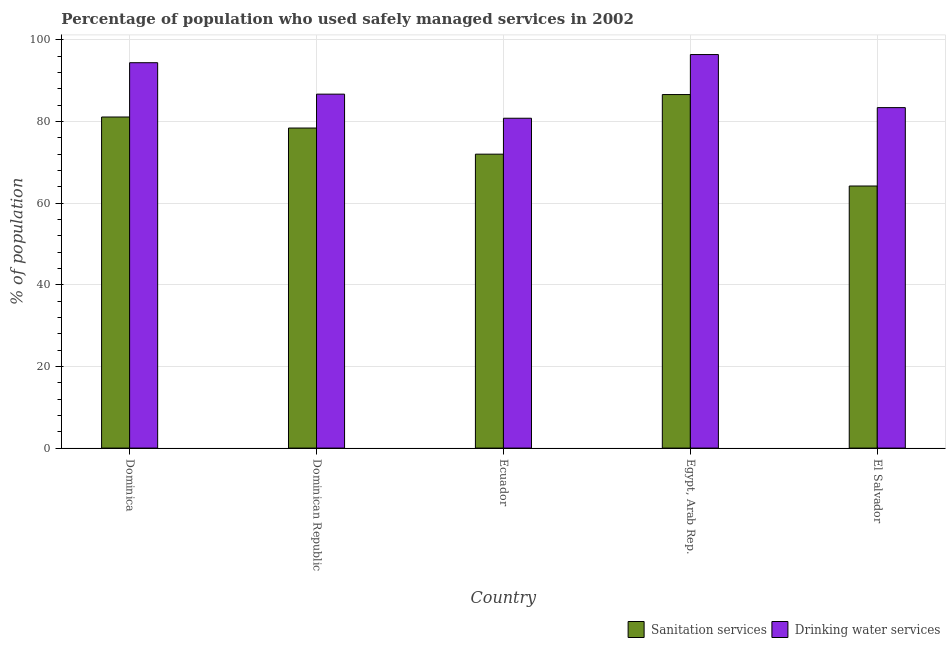Are the number of bars per tick equal to the number of legend labels?
Provide a short and direct response. Yes. Are the number of bars on each tick of the X-axis equal?
Provide a succinct answer. Yes. How many bars are there on the 2nd tick from the left?
Give a very brief answer. 2. What is the label of the 3rd group of bars from the left?
Provide a succinct answer. Ecuador. Across all countries, what is the maximum percentage of population who used sanitation services?
Your answer should be compact. 86.6. Across all countries, what is the minimum percentage of population who used drinking water services?
Your answer should be very brief. 80.8. In which country was the percentage of population who used sanitation services maximum?
Ensure brevity in your answer.  Egypt, Arab Rep. In which country was the percentage of population who used sanitation services minimum?
Make the answer very short. El Salvador. What is the total percentage of population who used sanitation services in the graph?
Give a very brief answer. 382.3. What is the difference between the percentage of population who used drinking water services in Dominican Republic and that in Egypt, Arab Rep.?
Your response must be concise. -9.7. What is the average percentage of population who used drinking water services per country?
Provide a short and direct response. 88.34. What is the difference between the percentage of population who used drinking water services and percentage of population who used sanitation services in Egypt, Arab Rep.?
Ensure brevity in your answer.  9.8. What is the ratio of the percentage of population who used drinking water services in Ecuador to that in Egypt, Arab Rep.?
Ensure brevity in your answer.  0.84. Is the percentage of population who used drinking water services in Dominica less than that in Dominican Republic?
Offer a very short reply. No. Is the difference between the percentage of population who used drinking water services in Ecuador and Egypt, Arab Rep. greater than the difference between the percentage of population who used sanitation services in Ecuador and Egypt, Arab Rep.?
Your answer should be very brief. No. What is the difference between the highest and the lowest percentage of population who used sanitation services?
Your answer should be compact. 22.4. In how many countries, is the percentage of population who used drinking water services greater than the average percentage of population who used drinking water services taken over all countries?
Your response must be concise. 2. What does the 2nd bar from the left in El Salvador represents?
Your answer should be very brief. Drinking water services. What does the 2nd bar from the right in Egypt, Arab Rep. represents?
Make the answer very short. Sanitation services. How many bars are there?
Offer a terse response. 10. Are all the bars in the graph horizontal?
Make the answer very short. No. What is the difference between two consecutive major ticks on the Y-axis?
Make the answer very short. 20. Does the graph contain any zero values?
Your response must be concise. No. How many legend labels are there?
Make the answer very short. 2. What is the title of the graph?
Offer a very short reply. Percentage of population who used safely managed services in 2002. What is the label or title of the Y-axis?
Ensure brevity in your answer.  % of population. What is the % of population of Sanitation services in Dominica?
Provide a short and direct response. 81.1. What is the % of population of Drinking water services in Dominica?
Provide a succinct answer. 94.4. What is the % of population of Sanitation services in Dominican Republic?
Offer a very short reply. 78.4. What is the % of population in Drinking water services in Dominican Republic?
Offer a terse response. 86.7. What is the % of population of Drinking water services in Ecuador?
Your answer should be very brief. 80.8. What is the % of population of Sanitation services in Egypt, Arab Rep.?
Your response must be concise. 86.6. What is the % of population of Drinking water services in Egypt, Arab Rep.?
Make the answer very short. 96.4. What is the % of population in Sanitation services in El Salvador?
Offer a very short reply. 64.2. What is the % of population in Drinking water services in El Salvador?
Provide a short and direct response. 83.4. Across all countries, what is the maximum % of population in Sanitation services?
Offer a terse response. 86.6. Across all countries, what is the maximum % of population of Drinking water services?
Make the answer very short. 96.4. Across all countries, what is the minimum % of population of Sanitation services?
Give a very brief answer. 64.2. Across all countries, what is the minimum % of population in Drinking water services?
Provide a short and direct response. 80.8. What is the total % of population of Sanitation services in the graph?
Your answer should be very brief. 382.3. What is the total % of population in Drinking water services in the graph?
Provide a short and direct response. 441.7. What is the difference between the % of population of Drinking water services in Dominica and that in Dominican Republic?
Provide a succinct answer. 7.7. What is the difference between the % of population in Sanitation services in Dominica and that in Ecuador?
Your response must be concise. 9.1. What is the difference between the % of population of Drinking water services in Dominica and that in Ecuador?
Make the answer very short. 13.6. What is the difference between the % of population in Sanitation services in Dominica and that in Egypt, Arab Rep.?
Give a very brief answer. -5.5. What is the difference between the % of population of Drinking water services in Dominica and that in Egypt, Arab Rep.?
Keep it short and to the point. -2. What is the difference between the % of population of Sanitation services in Dominican Republic and that in Ecuador?
Offer a very short reply. 6.4. What is the difference between the % of population in Drinking water services in Dominican Republic and that in Ecuador?
Keep it short and to the point. 5.9. What is the difference between the % of population in Sanitation services in Dominican Republic and that in Egypt, Arab Rep.?
Your answer should be very brief. -8.2. What is the difference between the % of population of Drinking water services in Dominican Republic and that in El Salvador?
Provide a succinct answer. 3.3. What is the difference between the % of population of Sanitation services in Ecuador and that in Egypt, Arab Rep.?
Offer a very short reply. -14.6. What is the difference between the % of population in Drinking water services in Ecuador and that in Egypt, Arab Rep.?
Ensure brevity in your answer.  -15.6. What is the difference between the % of population in Drinking water services in Ecuador and that in El Salvador?
Offer a terse response. -2.6. What is the difference between the % of population of Sanitation services in Egypt, Arab Rep. and that in El Salvador?
Provide a short and direct response. 22.4. What is the difference between the % of population of Sanitation services in Dominica and the % of population of Drinking water services in Ecuador?
Your response must be concise. 0.3. What is the difference between the % of population of Sanitation services in Dominica and the % of population of Drinking water services in Egypt, Arab Rep.?
Offer a terse response. -15.3. What is the difference between the % of population in Sanitation services in Dominica and the % of population in Drinking water services in El Salvador?
Keep it short and to the point. -2.3. What is the difference between the % of population of Sanitation services in Dominican Republic and the % of population of Drinking water services in Egypt, Arab Rep.?
Your answer should be compact. -18. What is the difference between the % of population in Sanitation services in Dominican Republic and the % of population in Drinking water services in El Salvador?
Provide a succinct answer. -5. What is the difference between the % of population of Sanitation services in Ecuador and the % of population of Drinking water services in Egypt, Arab Rep.?
Offer a terse response. -24.4. What is the difference between the % of population of Sanitation services in Ecuador and the % of population of Drinking water services in El Salvador?
Your response must be concise. -11.4. What is the average % of population in Sanitation services per country?
Offer a very short reply. 76.46. What is the average % of population of Drinking water services per country?
Offer a terse response. 88.34. What is the difference between the % of population in Sanitation services and % of population in Drinking water services in Dominican Republic?
Give a very brief answer. -8.3. What is the difference between the % of population of Sanitation services and % of population of Drinking water services in El Salvador?
Give a very brief answer. -19.2. What is the ratio of the % of population in Sanitation services in Dominica to that in Dominican Republic?
Your answer should be very brief. 1.03. What is the ratio of the % of population of Drinking water services in Dominica to that in Dominican Republic?
Offer a terse response. 1.09. What is the ratio of the % of population of Sanitation services in Dominica to that in Ecuador?
Offer a terse response. 1.13. What is the ratio of the % of population in Drinking water services in Dominica to that in Ecuador?
Your answer should be compact. 1.17. What is the ratio of the % of population of Sanitation services in Dominica to that in Egypt, Arab Rep.?
Your answer should be compact. 0.94. What is the ratio of the % of population of Drinking water services in Dominica to that in Egypt, Arab Rep.?
Your answer should be compact. 0.98. What is the ratio of the % of population in Sanitation services in Dominica to that in El Salvador?
Your response must be concise. 1.26. What is the ratio of the % of population in Drinking water services in Dominica to that in El Salvador?
Offer a very short reply. 1.13. What is the ratio of the % of population in Sanitation services in Dominican Republic to that in Ecuador?
Offer a terse response. 1.09. What is the ratio of the % of population in Drinking water services in Dominican Republic to that in Ecuador?
Your answer should be compact. 1.07. What is the ratio of the % of population in Sanitation services in Dominican Republic to that in Egypt, Arab Rep.?
Offer a very short reply. 0.91. What is the ratio of the % of population in Drinking water services in Dominican Republic to that in Egypt, Arab Rep.?
Provide a short and direct response. 0.9. What is the ratio of the % of population in Sanitation services in Dominican Republic to that in El Salvador?
Offer a terse response. 1.22. What is the ratio of the % of population in Drinking water services in Dominican Republic to that in El Salvador?
Keep it short and to the point. 1.04. What is the ratio of the % of population in Sanitation services in Ecuador to that in Egypt, Arab Rep.?
Your answer should be very brief. 0.83. What is the ratio of the % of population in Drinking water services in Ecuador to that in Egypt, Arab Rep.?
Ensure brevity in your answer.  0.84. What is the ratio of the % of population of Sanitation services in Ecuador to that in El Salvador?
Make the answer very short. 1.12. What is the ratio of the % of population of Drinking water services in Ecuador to that in El Salvador?
Ensure brevity in your answer.  0.97. What is the ratio of the % of population in Sanitation services in Egypt, Arab Rep. to that in El Salvador?
Offer a terse response. 1.35. What is the ratio of the % of population in Drinking water services in Egypt, Arab Rep. to that in El Salvador?
Provide a succinct answer. 1.16. What is the difference between the highest and the lowest % of population of Sanitation services?
Your response must be concise. 22.4. 